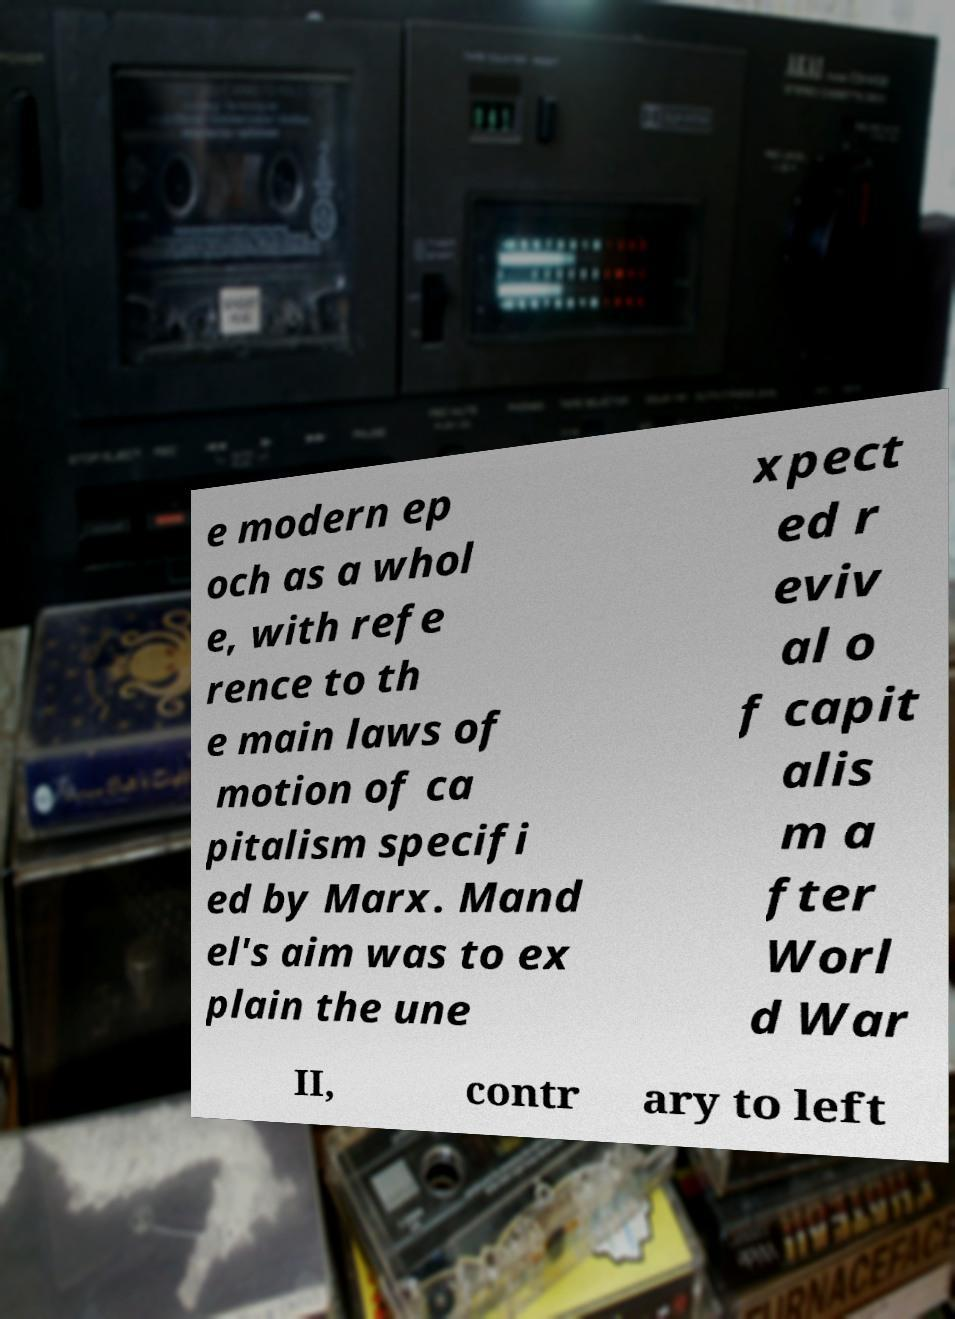I need the written content from this picture converted into text. Can you do that? e modern ep och as a whol e, with refe rence to th e main laws of motion of ca pitalism specifi ed by Marx. Mand el's aim was to ex plain the une xpect ed r eviv al o f capit alis m a fter Worl d War II, contr ary to left 